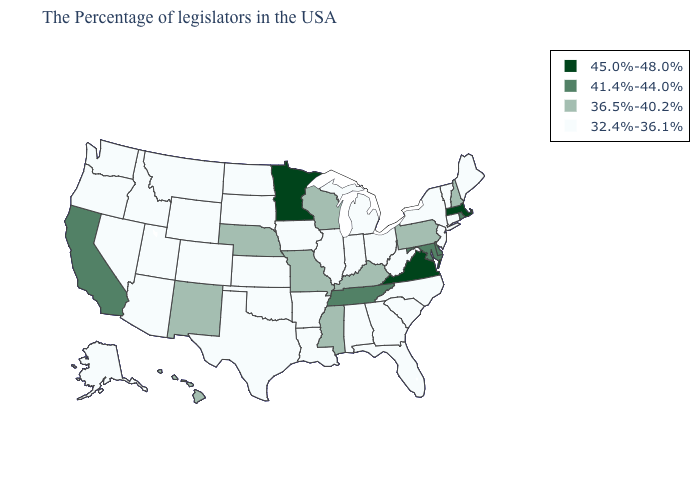What is the value of Missouri?
Short answer required. 36.5%-40.2%. Does Virginia have the highest value in the USA?
Quick response, please. Yes. Does Illinois have the same value as Arkansas?
Answer briefly. Yes. Does Mississippi have a higher value than Utah?
Be succinct. Yes. What is the lowest value in the USA?
Give a very brief answer. 32.4%-36.1%. Name the states that have a value in the range 41.4%-44.0%?
Concise answer only. Rhode Island, Delaware, Maryland, Tennessee, California. What is the value of Virginia?
Write a very short answer. 45.0%-48.0%. Does the map have missing data?
Concise answer only. No. What is the value of Minnesota?
Be succinct. 45.0%-48.0%. What is the value of Colorado?
Short answer required. 32.4%-36.1%. What is the value of Minnesota?
Be succinct. 45.0%-48.0%. Name the states that have a value in the range 32.4%-36.1%?
Quick response, please. Maine, Vermont, Connecticut, New York, New Jersey, North Carolina, South Carolina, West Virginia, Ohio, Florida, Georgia, Michigan, Indiana, Alabama, Illinois, Louisiana, Arkansas, Iowa, Kansas, Oklahoma, Texas, South Dakota, North Dakota, Wyoming, Colorado, Utah, Montana, Arizona, Idaho, Nevada, Washington, Oregon, Alaska. What is the highest value in the Northeast ?
Be succinct. 45.0%-48.0%. Which states have the lowest value in the USA?
Be succinct. Maine, Vermont, Connecticut, New York, New Jersey, North Carolina, South Carolina, West Virginia, Ohio, Florida, Georgia, Michigan, Indiana, Alabama, Illinois, Louisiana, Arkansas, Iowa, Kansas, Oklahoma, Texas, South Dakota, North Dakota, Wyoming, Colorado, Utah, Montana, Arizona, Idaho, Nevada, Washington, Oregon, Alaska. Which states hav the highest value in the Northeast?
Be succinct. Massachusetts. 